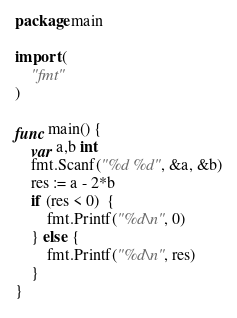<code> <loc_0><loc_0><loc_500><loc_500><_Go_>package main

import (
	"fmt"
)

func main() {
	var a,b int
	fmt.Scanf("%d %d", &a, &b)
	res := a - 2*b
	if (res < 0)  {
		fmt.Printf("%d\n", 0)
	} else {
		fmt.Printf("%d\n", res)
	}
}</code> 